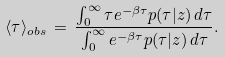<formula> <loc_0><loc_0><loc_500><loc_500>\langle \tau \rangle _ { o b s } \, = \, \frac { \int _ { 0 } ^ { \infty } \tau e ^ { - \beta \tau } p ( \tau | z ) \, d \tau } { \int _ { 0 } ^ { \infty } e ^ { - \beta \tau } p ( \tau | z ) \, d \tau } .</formula> 